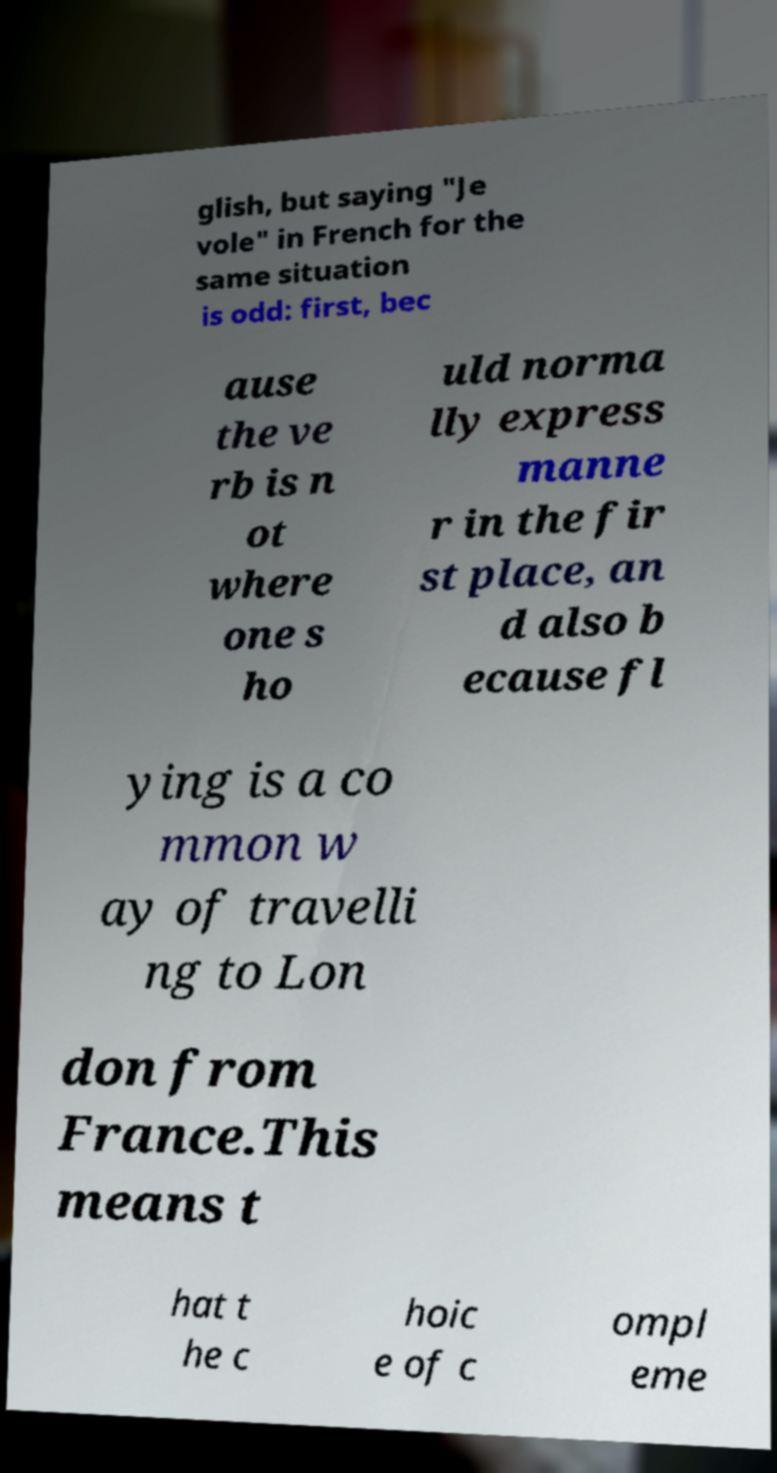Can you accurately transcribe the text from the provided image for me? glish, but saying "Je vole" in French for the same situation is odd: first, bec ause the ve rb is n ot where one s ho uld norma lly express manne r in the fir st place, an d also b ecause fl ying is a co mmon w ay of travelli ng to Lon don from France.This means t hat t he c hoic e of c ompl eme 